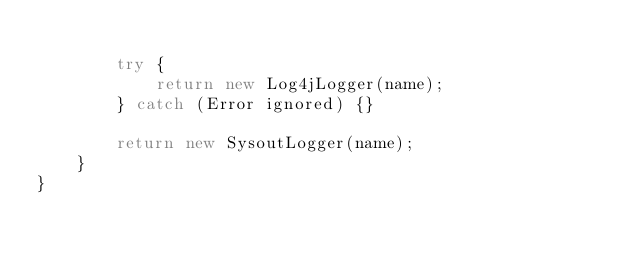<code> <loc_0><loc_0><loc_500><loc_500><_Java_>
        try {
            return new Log4jLogger(name);
        } catch (Error ignored) {}

        return new SysoutLogger(name);
    }
}
</code> 